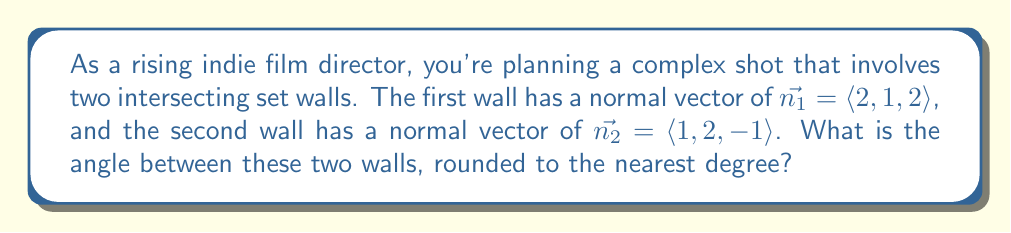Provide a solution to this math problem. To find the angle between two intersecting planes, we can use the dot product of their normal vectors. The formula for the angle $\theta$ between two planes with normal vectors $\vec{n_1}$ and $\vec{n_2}$ is:

$$\cos \theta = \frac{|\vec{n_1} \cdot \vec{n_2}|}{\|\vec{n_1}\| \|\vec{n_2}\|}$$

Let's solve this step by step:

1) First, calculate the dot product $\vec{n_1} \cdot \vec{n_2}$:
   $$\vec{n_1} \cdot \vec{n_2} = (2)(1) + (1)(2) + (2)(-1) = 2 + 2 - 2 = 2$$

2) Calculate the magnitudes of the normal vectors:
   $$\|\vec{n_1}\| = \sqrt{2^2 + 1^2 + 2^2} = \sqrt{9} = 3$$
   $$\|\vec{n_2}\| = \sqrt{1^2 + 2^2 + (-1)^2} = \sqrt{6}$$

3) Now, substitute these values into the formula:
   $$\cos \theta = \frac{|2|}{3\sqrt{6}} = \frac{2}{3\sqrt{6}}$$

4) To find $\theta$, we need to take the inverse cosine (arccos) of both sides:
   $$\theta = \arccos(\frac{2}{3\sqrt{6}})$$

5) Using a calculator and rounding to the nearest degree:
   $$\theta \approx 73°$$

This angle represents the dihedral angle between the two intersecting walls in your film set.
Answer: 73° 